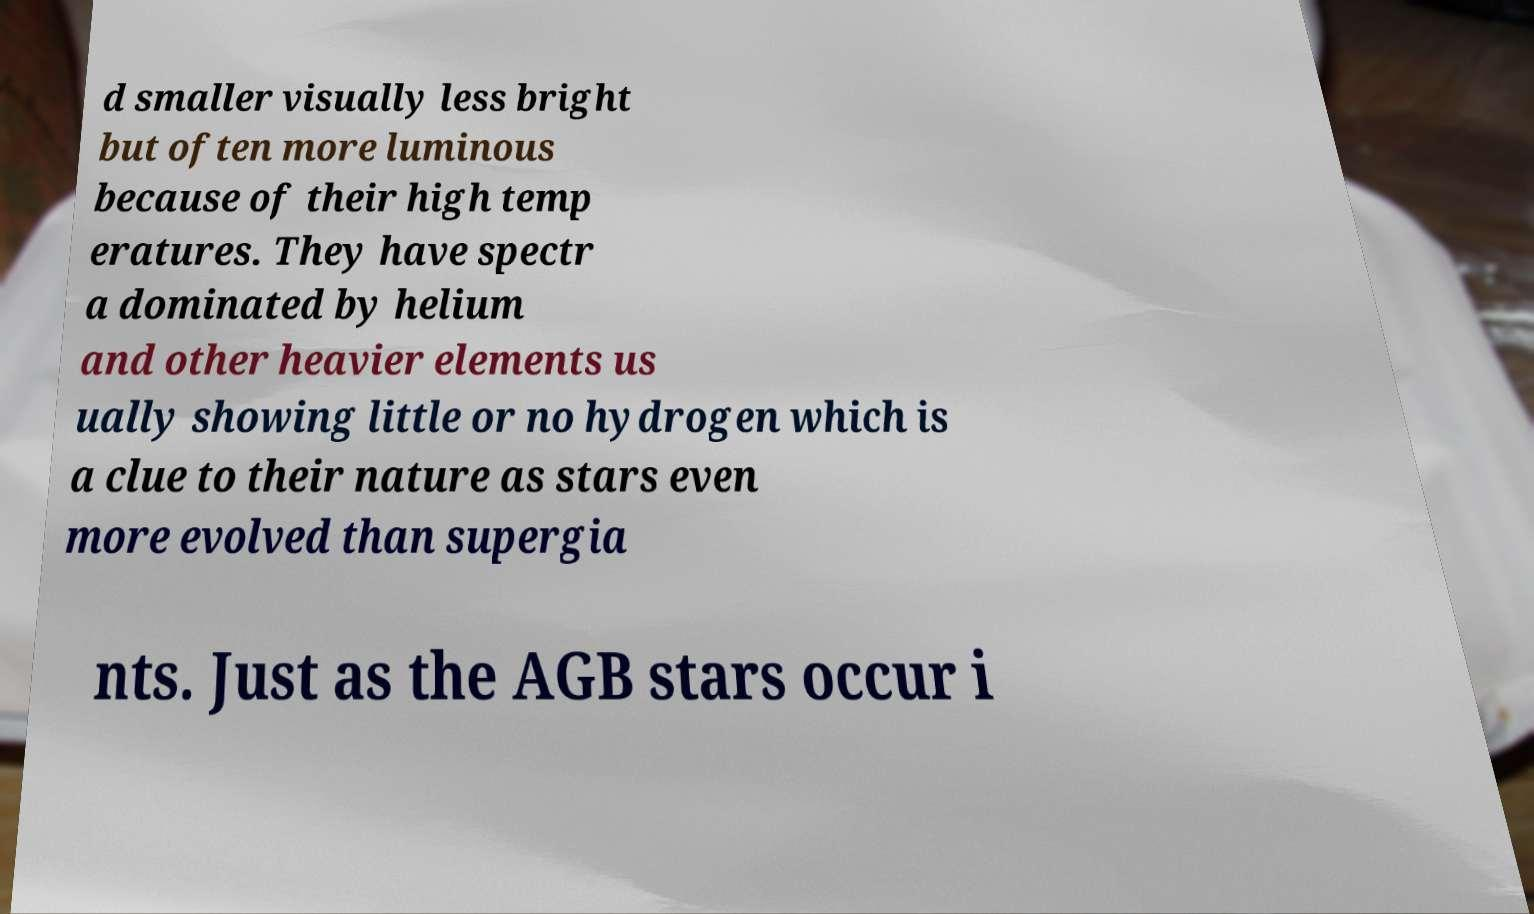Could you extract and type out the text from this image? d smaller visually less bright but often more luminous because of their high temp eratures. They have spectr a dominated by helium and other heavier elements us ually showing little or no hydrogen which is a clue to their nature as stars even more evolved than supergia nts. Just as the AGB stars occur i 